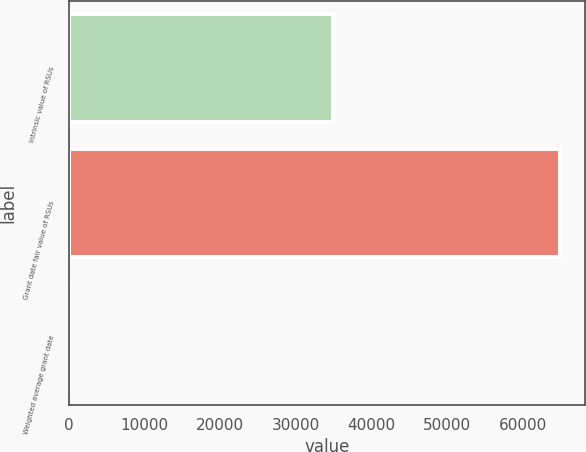Convert chart. <chart><loc_0><loc_0><loc_500><loc_500><bar_chart><fcel>Intrinsic value of RSUs<fcel>Grant date fair value of RSUs<fcel>Weighted average grant date<nl><fcel>34868<fcel>64973<fcel>10.36<nl></chart> 